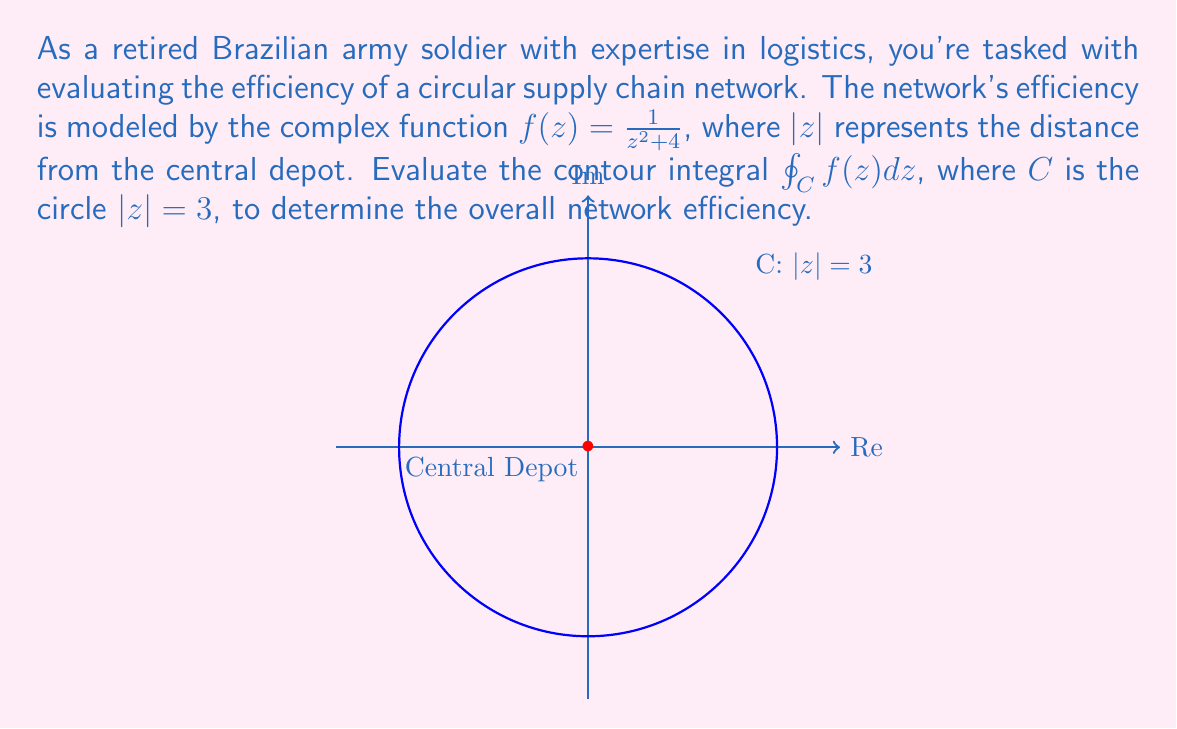Give your solution to this math problem. Let's approach this step-by-step using complex analysis techniques:

1) First, we need to check if the function $f(z) = \frac{1}{z^2 + 4}$ has any singularities inside the contour $C: |z| = 3$.

2) The singularities of $f(z)$ occur when $z^2 + 4 = 0$, i.e., when $z = \pm 2i$.

3) Since $|2i| = 2 < 3$, both singularities lie inside the contour $C$.

4) We can use the Residue Theorem, which states:
   $$\oint_C f(z) dz = 2\pi i \sum \text{Res}(f, a_k)$$
   where $a_k$ are the singularities inside $C$.

5) To find the residues, we need to expand $f(z)$ around each singularity:

   At $z = 2i$:
   $f(z) = \frac{1}{(z+2i)(z-2i)} = \frac{1}{2i(z-2i)} + \frac{1}{-2i(z+2i)}$
   $\text{Res}(f, 2i) = \frac{1}{4i}$

   At $z = -2i$:
   $f(z) = \frac{1}{(z-2i)(z+2i)} = \frac{1}{-2i(z-2i)} + \frac{1}{2i(z+2i)}$
   $\text{Res}(f, -2i) = \frac{1}{4i}$

6) Applying the Residue Theorem:
   $$\oint_C f(z) dz = 2\pi i (\frac{1}{4i} + \frac{1}{4i}) = 2\pi i \cdot \frac{1}{2i} = \pi$$

Therefore, the contour integral evaluates to $\pi$, representing the overall efficiency of the circular supply chain network.
Answer: $\pi$ 